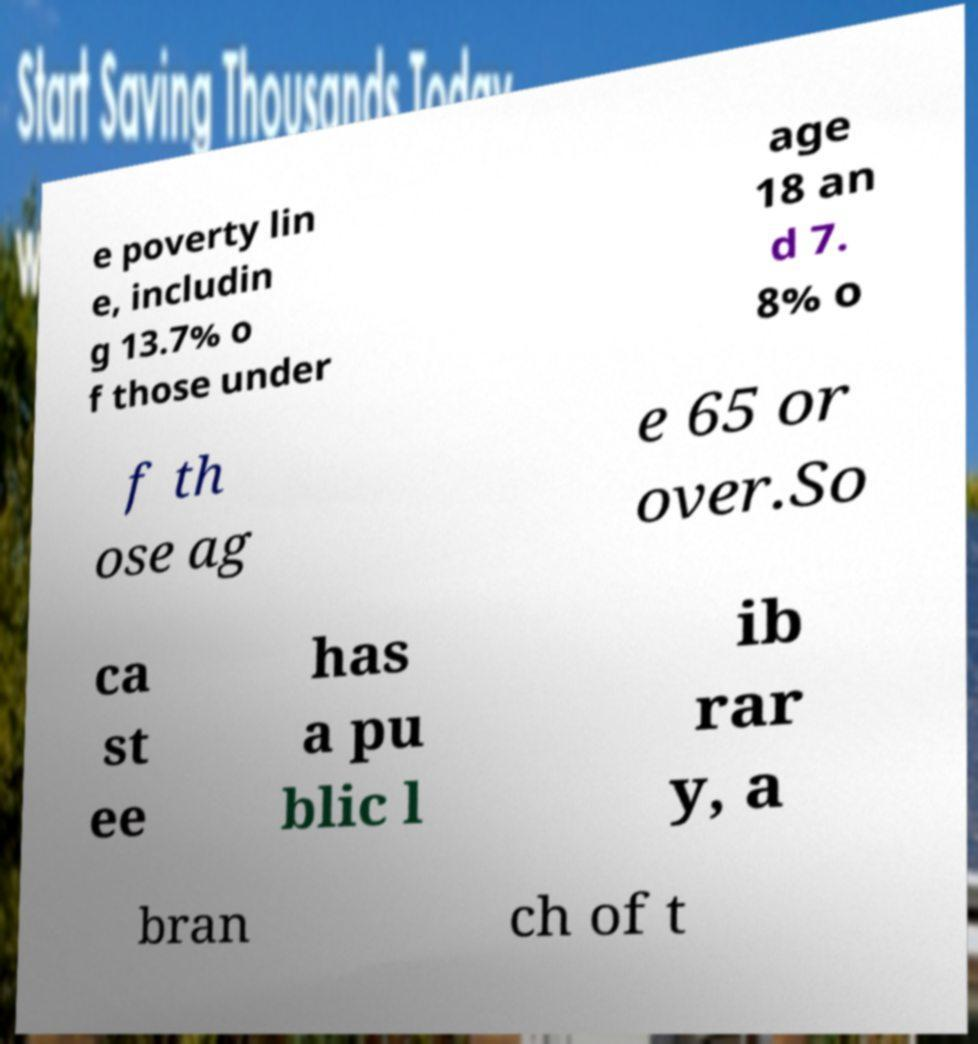Can you accurately transcribe the text from the provided image for me? e poverty lin e, includin g 13.7% o f those under age 18 an d 7. 8% o f th ose ag e 65 or over.So ca st ee has a pu blic l ib rar y, a bran ch of t 